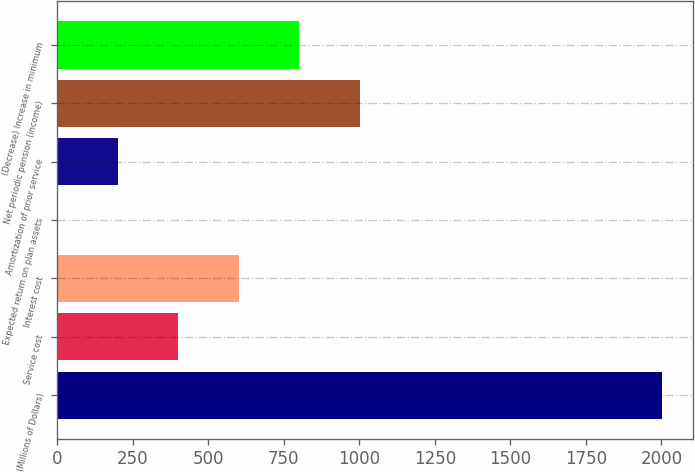Convert chart. <chart><loc_0><loc_0><loc_500><loc_500><bar_chart><fcel>(Millions of Dollars)<fcel>Service cost<fcel>Interest cost<fcel>Expected return on plan assets<fcel>Amortization of prior service<fcel>Net periodic pension (income)<fcel>(Decrease) Increase in minimum<nl><fcel>2003<fcel>401.4<fcel>601.6<fcel>1<fcel>201.2<fcel>1002<fcel>801.8<nl></chart> 